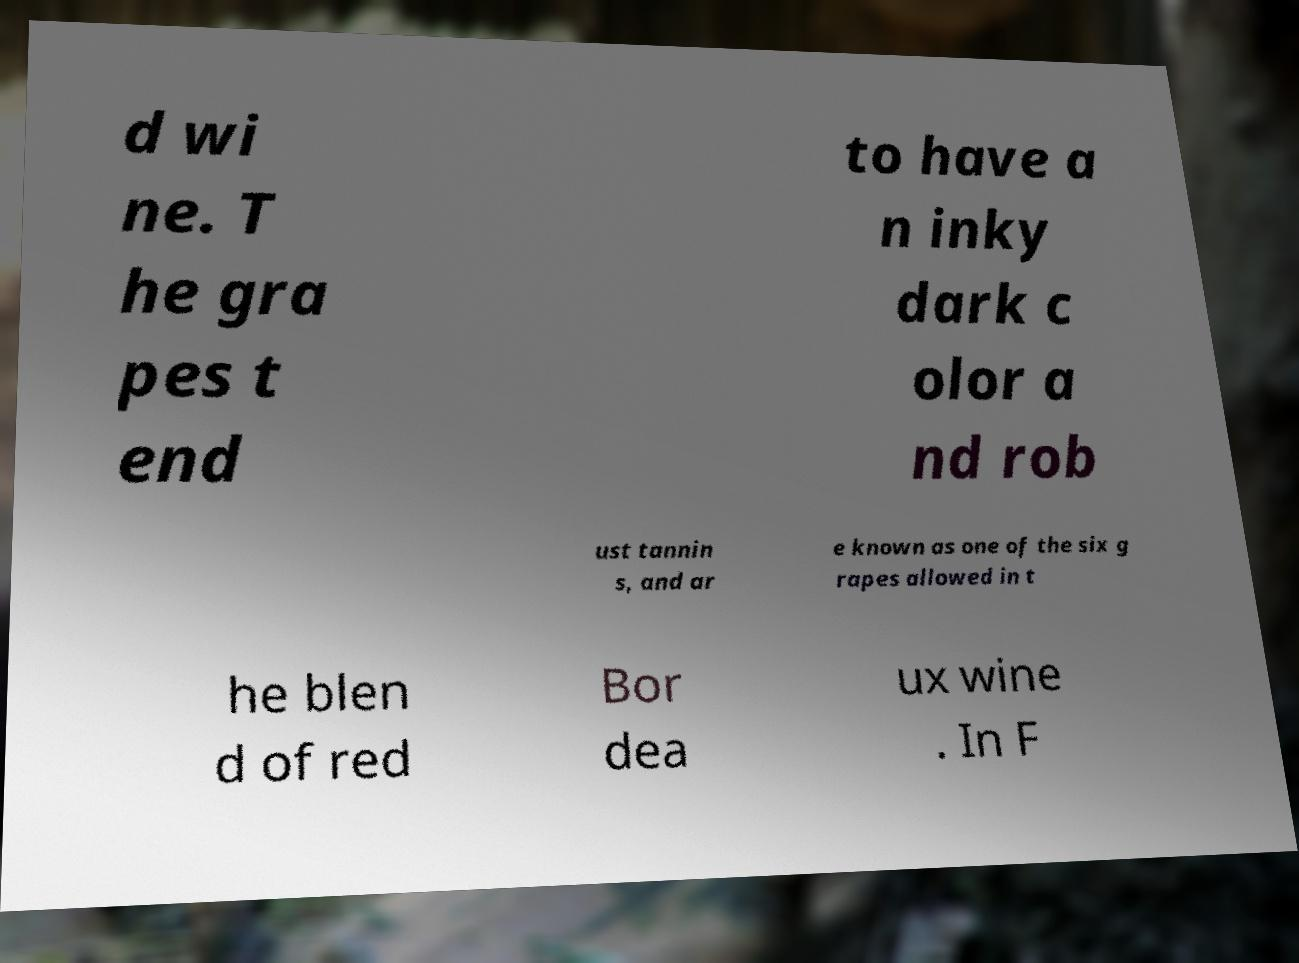There's text embedded in this image that I need extracted. Can you transcribe it verbatim? d wi ne. T he gra pes t end to have a n inky dark c olor a nd rob ust tannin s, and ar e known as one of the six g rapes allowed in t he blen d of red Bor dea ux wine . In F 